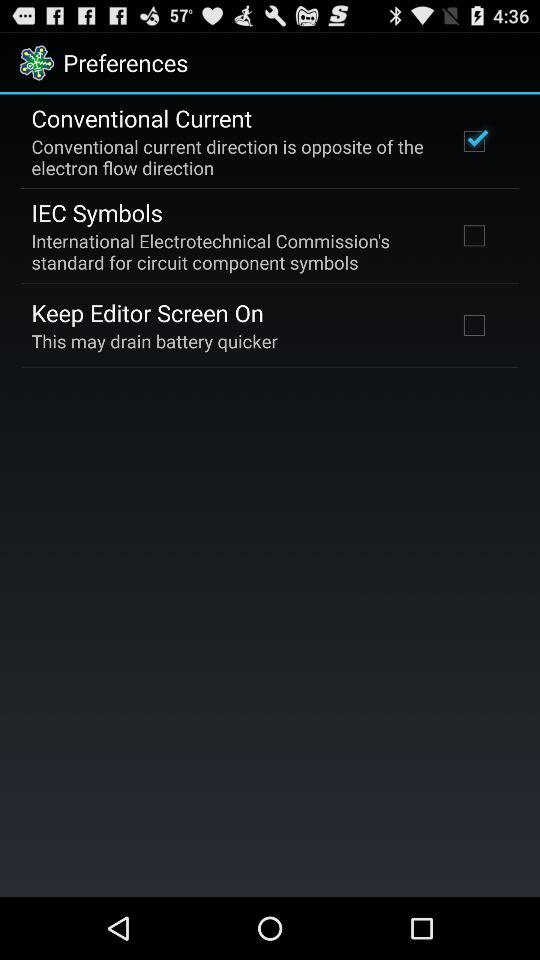How many checkboxes are in the preferences screen?
Answer the question using a single word or phrase. 3 